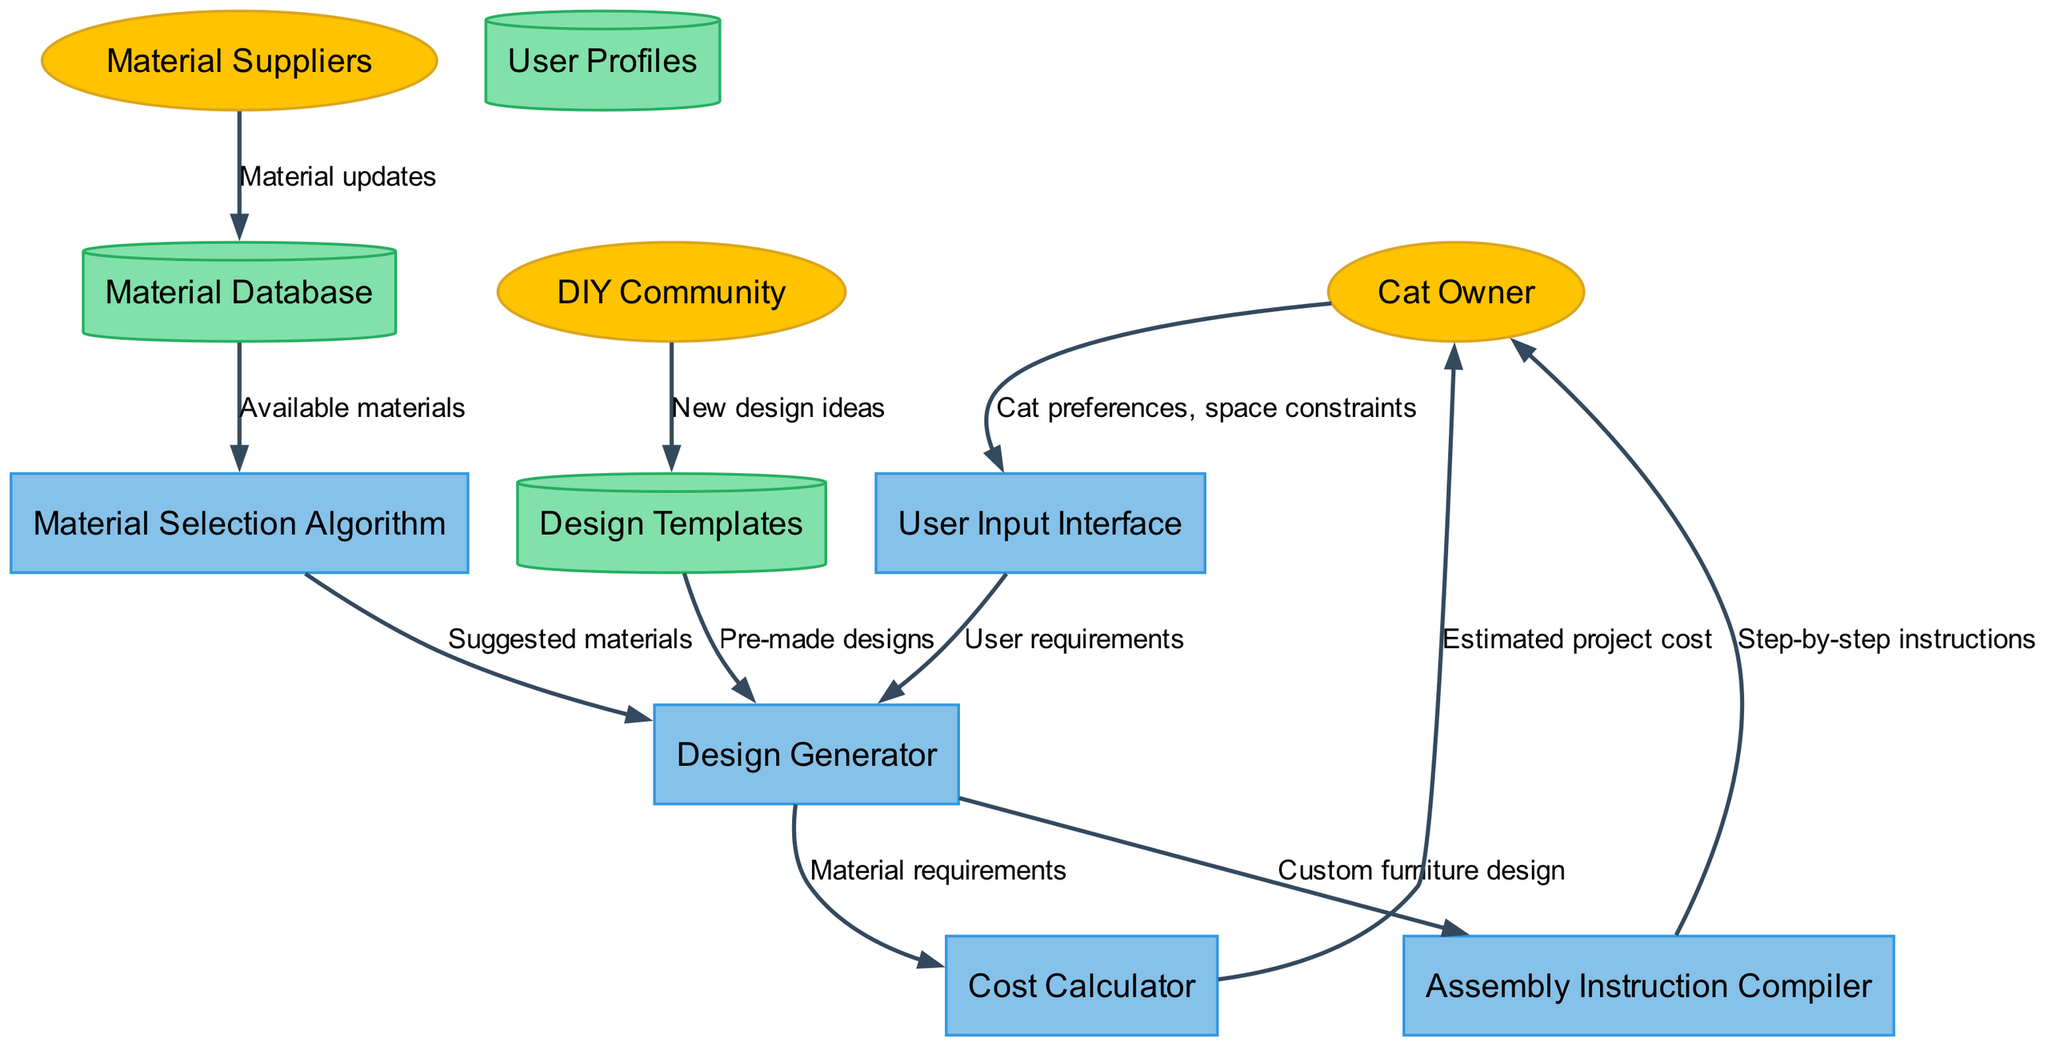What are the three external entities in the diagram? The diagram includes three external entities: Cat Owner, Material Suppliers, and DIY Community.
Answer: Cat Owner, Material Suppliers, DIY Community How many processes are there in the diagram? The diagram lists five processes: User Input Interface, Material Selection Algorithm, Design Generator, Assembly Instruction Compiler, and Cost Calculator.
Answer: Five What does the Cat Owner send to the User Input Interface? The Cat Owner sends their Cat preferences and space constraints to the User Input Interface.
Answer: Cat preferences, space constraints From which node does the Design Generator receive pre-made designs? The Design Generator receives pre-made designs from the Design Templates node in the flow of the diagram.
Answer: Design Templates What data flow leads to the Cat Owner after assembly instruction generation? Post assembly instruction generation, the flow directed towards the Cat Owner delivers step-by-step instructions compiled by the Assembly Instruction Compiler.
Answer: Step-by-step instructions Which nodes provide input to the Material Selection Algorithm? The Material Selection Algorithm receives data from the Material Database, which contains available materials.
Answer: Material Database How does the Cost Calculator get its input? The Cost Calculator obtains its input from the Design Generator, specifically the Material requirements necessary for the custom furniture design.
Answer: Material requirements Which external entity provides new design ideas to the Design Templates? New design ideas are contributed to the Design Templates from the DIY Community, according to the data flow in the diagram.
Answer: DIY Community What does the Cost Calculator deliver to the Cat Owner? Following the calculations of material costs, the Cost Calculator delivers the estimated project cost to the Cat Owner.
Answer: Estimated project cost 